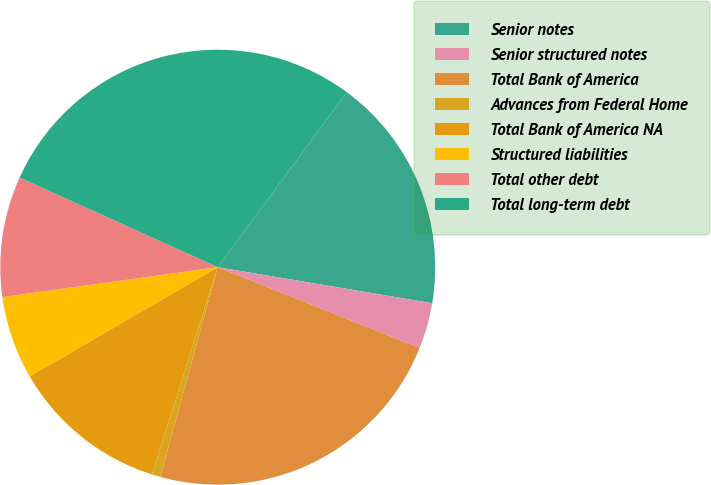Convert chart. <chart><loc_0><loc_0><loc_500><loc_500><pie_chart><fcel>Senior notes<fcel>Senior structured notes<fcel>Total Bank of America<fcel>Advances from Federal Home<fcel>Total Bank of America NA<fcel>Structured liabilities<fcel>Total other debt<fcel>Total long-term debt<nl><fcel>17.53%<fcel>3.41%<fcel>23.19%<fcel>0.64%<fcel>11.73%<fcel>6.18%<fcel>8.96%<fcel>28.36%<nl></chart> 